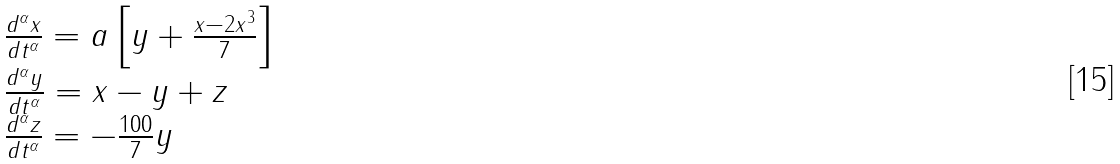Convert formula to latex. <formula><loc_0><loc_0><loc_500><loc_500>\begin{array} { l } \frac { d ^ { \alpha } x } { d t ^ { \alpha } } = a \left [ y + \frac { x - 2 x ^ { 3 } } { 7 } \right ] \\ \frac { d ^ { \alpha } y } { d t ^ { \alpha } } = x - y + z \\ \frac { d ^ { \alpha } z } { d t ^ { \alpha } } = - \frac { 1 0 0 } { 7 } y \end{array}</formula> 